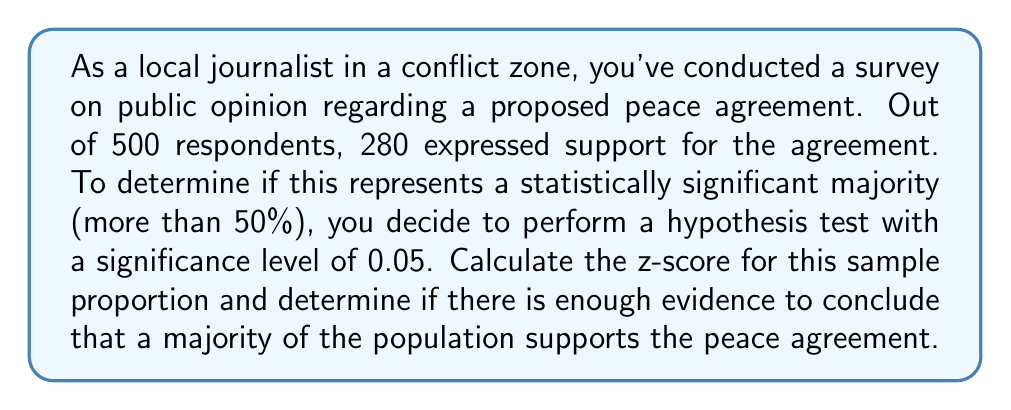Give your solution to this math problem. To solve this problem, we'll follow these steps:

1) First, let's define our hypotheses:
   $H_0: p = 0.5$ (null hypothesis: 50% of the population supports the agreement)
   $H_a: p > 0.5$ (alternative hypothesis: more than 50% of the population supports the agreement)

2) We'll use the z-test for a population proportion. The formula for the z-score is:

   $$z = \frac{\hat{p} - p_0}{\sqrt{\frac{p_0(1-p_0)}{n}}}$$

   Where:
   $\hat{p}$ is the sample proportion
   $p_0$ is the hypothesized population proportion
   $n$ is the sample size

3) Calculate the sample proportion:
   $\hat{p} = \frac{280}{500} = 0.56$

4) We know:
   $p_0 = 0.5$ (from the null hypothesis)
   $n = 500$ (sample size)

5) Now, let's plug these values into our z-score formula:

   $$z = \frac{0.56 - 0.5}{\sqrt{\frac{0.5(1-0.5)}{500}}}$$

6) Simplify:
   $$z = \frac{0.06}{\sqrt{\frac{0.25}{500}}} = \frac{0.06}{0.0224} = 2.68$$

7) To determine statistical significance, we compare this z-score to the critical value for a one-tailed test at α = 0.05, which is 1.645.

8) Since our calculated z-score (2.68) is greater than the critical value (1.645), we reject the null hypothesis.

Therefore, there is enough evidence to conclude that a majority of the population supports the peace agreement at a 0.05 significance level.
Answer: The z-score is 2.68. Since 2.68 > 1.645 (the critical value at α = 0.05 for a one-tailed test), we reject the null hypothesis. There is statistically significant evidence that a majority of the population supports the peace agreement. 